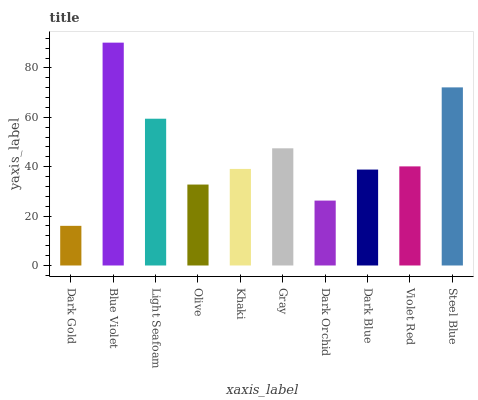Is Dark Gold the minimum?
Answer yes or no. Yes. Is Blue Violet the maximum?
Answer yes or no. Yes. Is Light Seafoam the minimum?
Answer yes or no. No. Is Light Seafoam the maximum?
Answer yes or no. No. Is Blue Violet greater than Light Seafoam?
Answer yes or no. Yes. Is Light Seafoam less than Blue Violet?
Answer yes or no. Yes. Is Light Seafoam greater than Blue Violet?
Answer yes or no. No. Is Blue Violet less than Light Seafoam?
Answer yes or no. No. Is Violet Red the high median?
Answer yes or no. Yes. Is Khaki the low median?
Answer yes or no. Yes. Is Khaki the high median?
Answer yes or no. No. Is Dark Blue the low median?
Answer yes or no. No. 